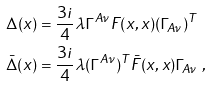Convert formula to latex. <formula><loc_0><loc_0><loc_500><loc_500>\Delta ( x ) & = \frac { 3 i } { 4 } \lambda \Gamma ^ { A \nu } F ( x , x ) ( \Gamma _ { A \nu } ) ^ { T } \\ \bar { \Delta } ( x ) & = \frac { 3 i } { 4 } \lambda ( \Gamma ^ { A \nu } ) ^ { T } \bar { F } ( x , x ) \Gamma _ { A \nu } \ ,</formula> 